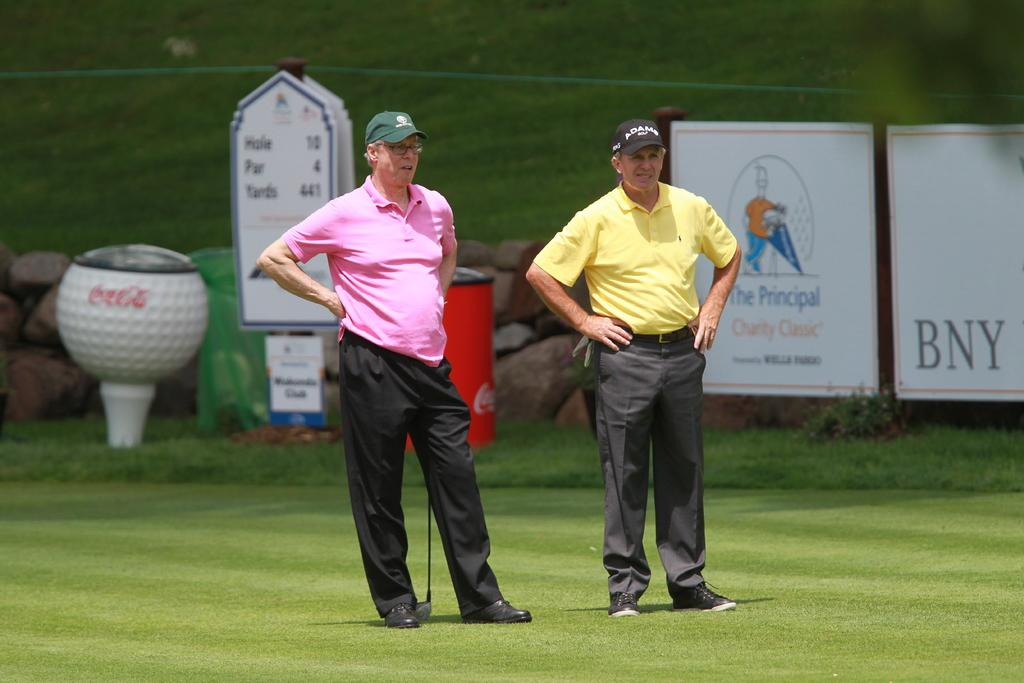Provide a one-sentence caption for the provided image. Two men wearing golf shirts and pants standing at the 10th hole par 4 tee box. 